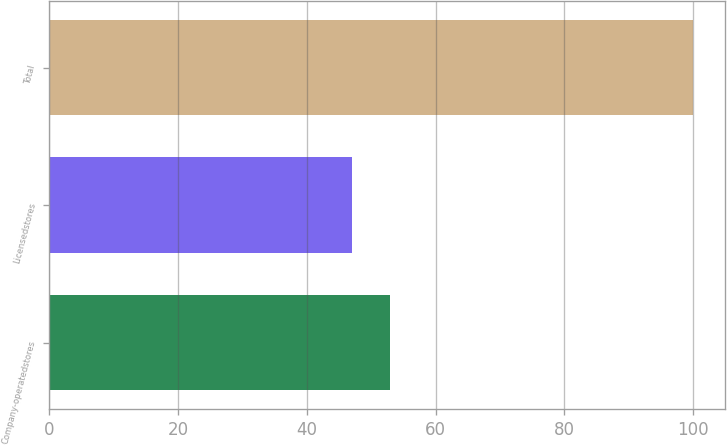Convert chart. <chart><loc_0><loc_0><loc_500><loc_500><bar_chart><fcel>Company-operatedstores<fcel>Licensedstores<fcel>Total<nl><fcel>53<fcel>47<fcel>100<nl></chart> 